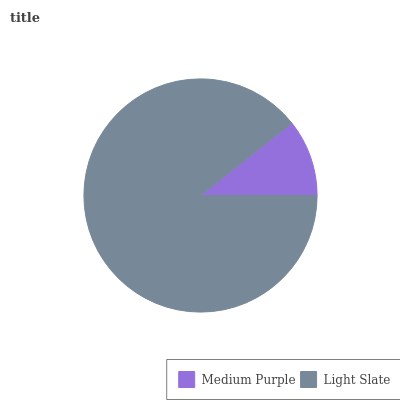Is Medium Purple the minimum?
Answer yes or no. Yes. Is Light Slate the maximum?
Answer yes or no. Yes. Is Light Slate the minimum?
Answer yes or no. No. Is Light Slate greater than Medium Purple?
Answer yes or no. Yes. Is Medium Purple less than Light Slate?
Answer yes or no. Yes. Is Medium Purple greater than Light Slate?
Answer yes or no. No. Is Light Slate less than Medium Purple?
Answer yes or no. No. Is Light Slate the high median?
Answer yes or no. Yes. Is Medium Purple the low median?
Answer yes or no. Yes. Is Medium Purple the high median?
Answer yes or no. No. Is Light Slate the low median?
Answer yes or no. No. 